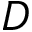<formula> <loc_0><loc_0><loc_500><loc_500>D</formula> 